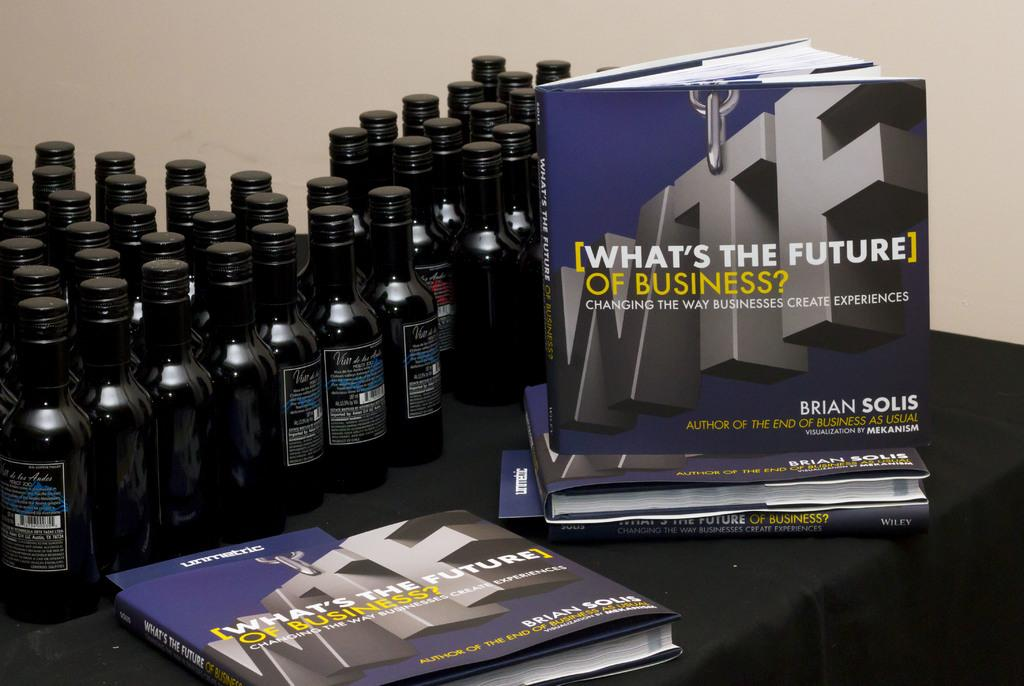<image>
Offer a succinct explanation of the picture presented. Book display called "What's The Future of Business" next to black bottles. 